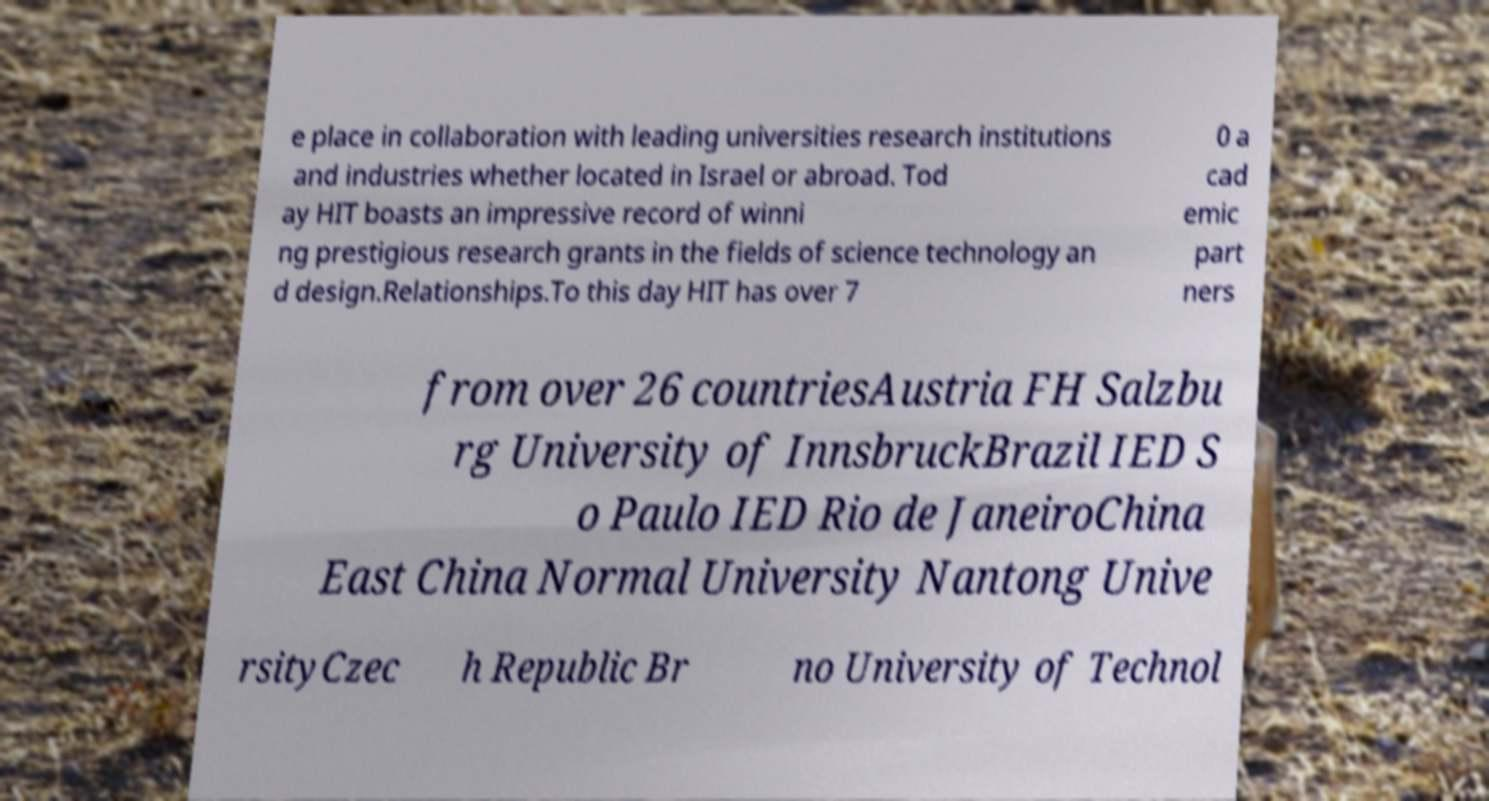Please identify and transcribe the text found in this image. e place in collaboration with leading universities research institutions and industries whether located in Israel or abroad. Tod ay HIT boasts an impressive record of winni ng prestigious research grants in the fields of science technology an d design.Relationships.To this day HIT has over 7 0 a cad emic part ners from over 26 countriesAustria FH Salzbu rg University of InnsbruckBrazil IED S o Paulo IED Rio de JaneiroChina East China Normal University Nantong Unive rsityCzec h Republic Br no University of Technol 